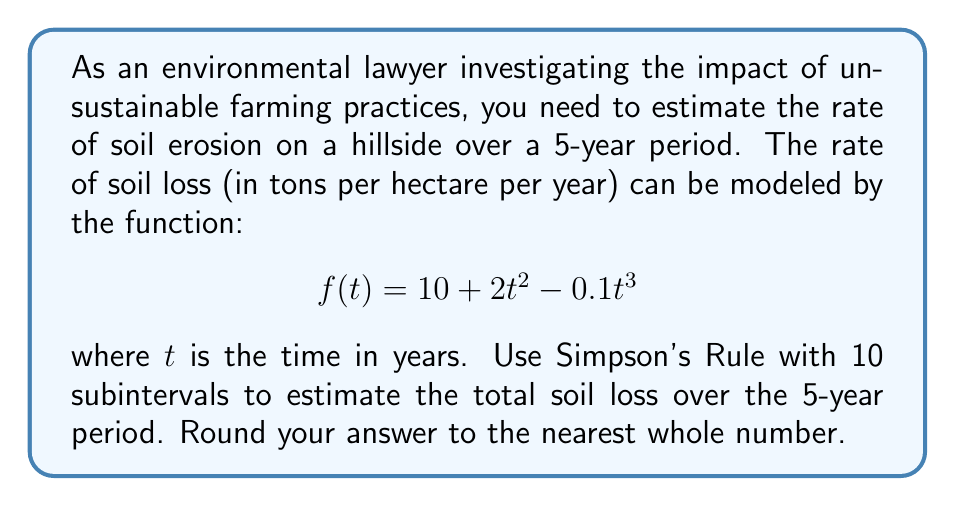Show me your answer to this math problem. To solve this problem, we'll use Simpson's Rule for numerical integration. Simpson's Rule is given by:

$$\int_{a}^{b} f(x) dx \approx \frac{h}{3}\left[f(x_0) + 4f(x_1) + 2f(x_2) + 4f(x_3) + ... + 2f(x_{n-2}) + 4f(x_{n-1}) + f(x_n)\right]$$

where $h = \frac{b-a}{n}$, $n$ is the number of subintervals (even), and $x_i = a + ih$.

Steps:
1) We have $a=0$, $b=5$, and $n=10$.
2) Calculate $h$: $h = \frac{5-0}{10} = 0.5$
3) Generate $x_i$ values: $x_i = 0, 0.5, 1, 1.5, ..., 4.5, 5$
4) Calculate $f(x_i)$ for each $x_i$:
   $f(0) = 10$
   $f(0.5) = 10.475$
   $f(1) = 11.9$
   $f(1.5) = 13.775$
   $f(2) = 15.6$
   $f(2.5) = 17.075$
   $f(3) = 18$
   $f(3.5) = 18.275$
   $f(4) = 17.8$
   $f(4.5) = 16.575$
   $f(5) = 14.5$

5) Apply Simpson's Rule:
   $$\frac{0.5}{3}[10 + 4(10.475) + 2(11.9) + 4(13.775) + 2(15.6) + 4(17.075) + 2(18) + 4(18.275) + 2(17.8) + 4(16.575) + 14.5]$$

6) Simplify:
   $$\frac{0.5}{3}[10 + 41.9 + 23.8 + 55.1 + 31.2 + 68.3 + 36 + 73.1 + 35.6 + 66.3 + 14.5] = \frac{0.5}{3}(455.8) = 75.9667$$

This result represents the total soil loss in tons per hectare over the 5-year period.
Answer: 76 tons per hectare 